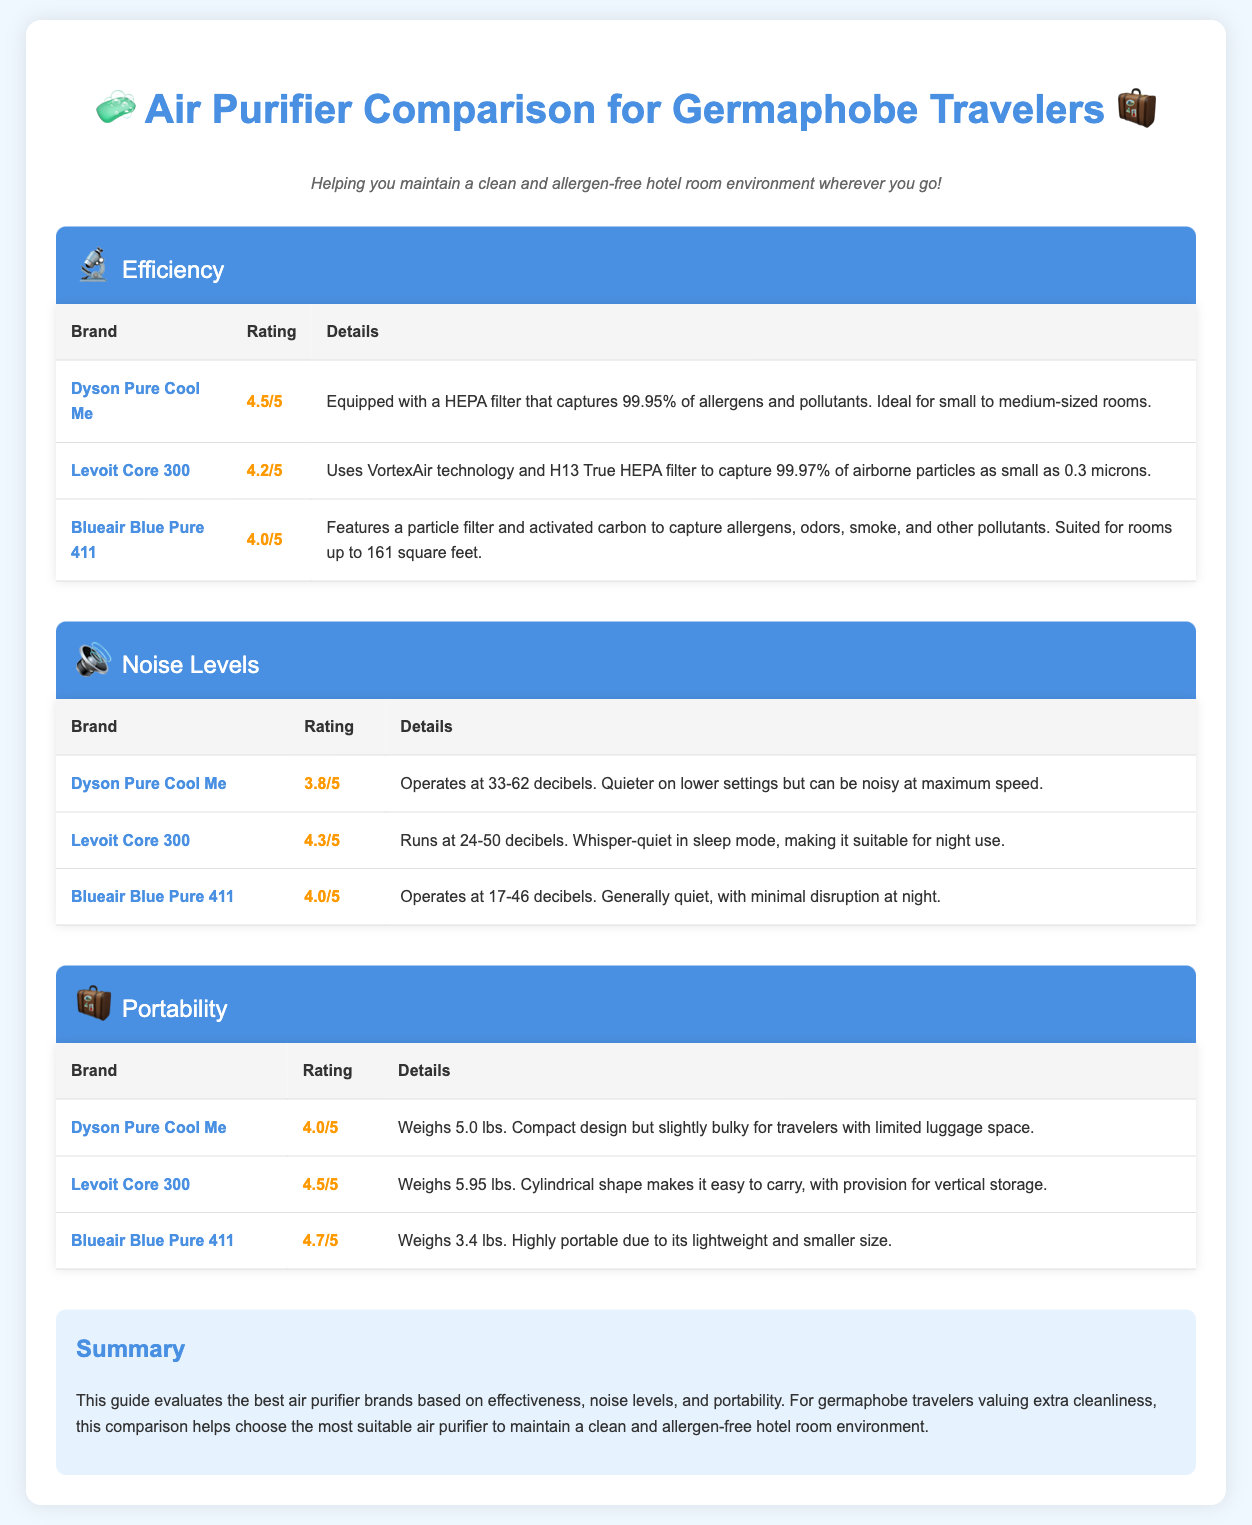What is the rating of Dyson Pure Cool Me for efficiency? The rating for Dyson Pure Cool Me in efficiency is stated in the document as 4.5/5.
Answer: 4.5/5 What technology does Levoit Core 300 use? The document mentions that Levoit Core 300 uses VortexAir technology and H13 True HEPA filter.
Answer: VortexAir technology and H13 True HEPA filter How many decibels does the Blueair Blue Pure 411 operate at? The Blueair Blue Pure 411 operates at 17-46 decibels according to the noise levels section.
Answer: 17-46 decibels Which air purifier is the lightest? The lightest air purifier listed in the document is Blueair Blue Pure 411, which weighs 3.4 lbs.
Answer: 3.4 lbs What is the portability rating of Levoit Core 300? The portability rating of Levoit Core 300 as per the table is 4.5/5.
Answer: 4.5/5 Which air purifier has the best noise level rating? The air purifier with the best noise level rating is Levoit Core 300 with a rating of 4.3/5.
Answer: Levoit Core 300 What features does the Blueair Blue Pure 411 include? The document states that it features a particle filter and activated carbon to capture allergens, odors, smoke, and other pollutants.
Answer: Particle filter and activated carbon Which brand is suggested for small to medium-sized rooms based on efficiency? The suggested brand for small to medium-sized rooms based on efficiency is Dyson Pure Cool Me.
Answer: Dyson Pure Cool Me What is the main focus of this comparison infographic? The main focus of this infographic is to evaluate air purifier brands for their effectiveness, noise levels, and portability, specifically for germaphobe travelers.
Answer: Evaluate air purifier brands for effectiveness, noise levels, and portability 